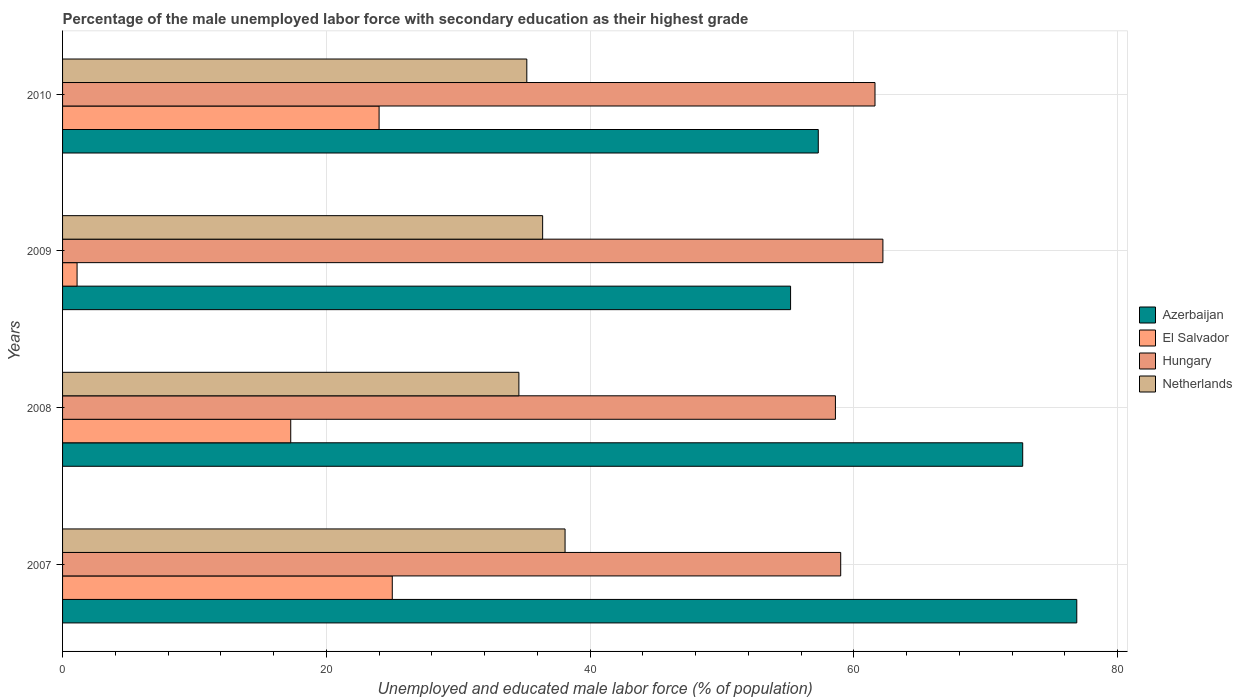How many different coloured bars are there?
Give a very brief answer. 4. Are the number of bars on each tick of the Y-axis equal?
Keep it short and to the point. Yes. How many bars are there on the 3rd tick from the bottom?
Your answer should be very brief. 4. What is the label of the 4th group of bars from the top?
Your answer should be very brief. 2007. What is the percentage of the unemployed male labor force with secondary education in Azerbaijan in 2007?
Provide a succinct answer. 76.9. Across all years, what is the maximum percentage of the unemployed male labor force with secondary education in Hungary?
Offer a very short reply. 62.2. Across all years, what is the minimum percentage of the unemployed male labor force with secondary education in Hungary?
Give a very brief answer. 58.6. In which year was the percentage of the unemployed male labor force with secondary education in El Salvador maximum?
Offer a terse response. 2007. In which year was the percentage of the unemployed male labor force with secondary education in Hungary minimum?
Make the answer very short. 2008. What is the total percentage of the unemployed male labor force with secondary education in Hungary in the graph?
Offer a very short reply. 241.4. What is the difference between the percentage of the unemployed male labor force with secondary education in Hungary in 2008 and that in 2010?
Keep it short and to the point. -3. What is the difference between the percentage of the unemployed male labor force with secondary education in Azerbaijan in 2008 and the percentage of the unemployed male labor force with secondary education in Netherlands in 2007?
Make the answer very short. 34.7. What is the average percentage of the unemployed male labor force with secondary education in Hungary per year?
Keep it short and to the point. 60.35. In the year 2007, what is the difference between the percentage of the unemployed male labor force with secondary education in Netherlands and percentage of the unemployed male labor force with secondary education in Hungary?
Offer a very short reply. -20.9. In how many years, is the percentage of the unemployed male labor force with secondary education in Netherlands greater than 72 %?
Your answer should be very brief. 0. What is the ratio of the percentage of the unemployed male labor force with secondary education in Hungary in 2009 to that in 2010?
Provide a succinct answer. 1.01. Is the difference between the percentage of the unemployed male labor force with secondary education in Netherlands in 2008 and 2009 greater than the difference between the percentage of the unemployed male labor force with secondary education in Hungary in 2008 and 2009?
Keep it short and to the point. Yes. What is the difference between the highest and the second highest percentage of the unemployed male labor force with secondary education in Hungary?
Offer a very short reply. 0.6. What is the difference between the highest and the lowest percentage of the unemployed male labor force with secondary education in El Salvador?
Your answer should be compact. 23.9. Is the sum of the percentage of the unemployed male labor force with secondary education in Netherlands in 2008 and 2009 greater than the maximum percentage of the unemployed male labor force with secondary education in Hungary across all years?
Offer a terse response. Yes. What does the 2nd bar from the top in 2008 represents?
Your answer should be compact. Hungary. What does the 3rd bar from the bottom in 2007 represents?
Your answer should be very brief. Hungary. Are all the bars in the graph horizontal?
Provide a short and direct response. Yes. How many years are there in the graph?
Your answer should be compact. 4. Does the graph contain grids?
Provide a short and direct response. Yes. How are the legend labels stacked?
Provide a short and direct response. Vertical. What is the title of the graph?
Your answer should be compact. Percentage of the male unemployed labor force with secondary education as their highest grade. Does "Cabo Verde" appear as one of the legend labels in the graph?
Ensure brevity in your answer.  No. What is the label or title of the X-axis?
Your answer should be very brief. Unemployed and educated male labor force (% of population). What is the Unemployed and educated male labor force (% of population) in Azerbaijan in 2007?
Offer a terse response. 76.9. What is the Unemployed and educated male labor force (% of population) in Hungary in 2007?
Your answer should be compact. 59. What is the Unemployed and educated male labor force (% of population) in Netherlands in 2007?
Keep it short and to the point. 38.1. What is the Unemployed and educated male labor force (% of population) in Azerbaijan in 2008?
Offer a very short reply. 72.8. What is the Unemployed and educated male labor force (% of population) in El Salvador in 2008?
Offer a very short reply. 17.3. What is the Unemployed and educated male labor force (% of population) in Hungary in 2008?
Provide a short and direct response. 58.6. What is the Unemployed and educated male labor force (% of population) in Netherlands in 2008?
Offer a very short reply. 34.6. What is the Unemployed and educated male labor force (% of population) of Azerbaijan in 2009?
Your answer should be very brief. 55.2. What is the Unemployed and educated male labor force (% of population) in El Salvador in 2009?
Give a very brief answer. 1.1. What is the Unemployed and educated male labor force (% of population) in Hungary in 2009?
Ensure brevity in your answer.  62.2. What is the Unemployed and educated male labor force (% of population) of Netherlands in 2009?
Offer a terse response. 36.4. What is the Unemployed and educated male labor force (% of population) of Azerbaijan in 2010?
Provide a short and direct response. 57.3. What is the Unemployed and educated male labor force (% of population) in El Salvador in 2010?
Make the answer very short. 24. What is the Unemployed and educated male labor force (% of population) of Hungary in 2010?
Offer a very short reply. 61.6. What is the Unemployed and educated male labor force (% of population) in Netherlands in 2010?
Keep it short and to the point. 35.2. Across all years, what is the maximum Unemployed and educated male labor force (% of population) in Azerbaijan?
Keep it short and to the point. 76.9. Across all years, what is the maximum Unemployed and educated male labor force (% of population) of El Salvador?
Give a very brief answer. 25. Across all years, what is the maximum Unemployed and educated male labor force (% of population) of Hungary?
Your answer should be very brief. 62.2. Across all years, what is the maximum Unemployed and educated male labor force (% of population) of Netherlands?
Your answer should be compact. 38.1. Across all years, what is the minimum Unemployed and educated male labor force (% of population) of Azerbaijan?
Your response must be concise. 55.2. Across all years, what is the minimum Unemployed and educated male labor force (% of population) in El Salvador?
Offer a very short reply. 1.1. Across all years, what is the minimum Unemployed and educated male labor force (% of population) of Hungary?
Make the answer very short. 58.6. Across all years, what is the minimum Unemployed and educated male labor force (% of population) of Netherlands?
Your answer should be very brief. 34.6. What is the total Unemployed and educated male labor force (% of population) of Azerbaijan in the graph?
Make the answer very short. 262.2. What is the total Unemployed and educated male labor force (% of population) of El Salvador in the graph?
Make the answer very short. 67.4. What is the total Unemployed and educated male labor force (% of population) of Hungary in the graph?
Ensure brevity in your answer.  241.4. What is the total Unemployed and educated male labor force (% of population) in Netherlands in the graph?
Keep it short and to the point. 144.3. What is the difference between the Unemployed and educated male labor force (% of population) in Azerbaijan in 2007 and that in 2008?
Offer a terse response. 4.1. What is the difference between the Unemployed and educated male labor force (% of population) in Hungary in 2007 and that in 2008?
Offer a very short reply. 0.4. What is the difference between the Unemployed and educated male labor force (% of population) in Azerbaijan in 2007 and that in 2009?
Your response must be concise. 21.7. What is the difference between the Unemployed and educated male labor force (% of population) in El Salvador in 2007 and that in 2009?
Offer a terse response. 23.9. What is the difference between the Unemployed and educated male labor force (% of population) of Azerbaijan in 2007 and that in 2010?
Your response must be concise. 19.6. What is the difference between the Unemployed and educated male labor force (% of population) of El Salvador in 2007 and that in 2010?
Provide a short and direct response. 1. What is the difference between the Unemployed and educated male labor force (% of population) of Hungary in 2007 and that in 2010?
Offer a very short reply. -2.6. What is the difference between the Unemployed and educated male labor force (% of population) of Azerbaijan in 2008 and that in 2009?
Ensure brevity in your answer.  17.6. What is the difference between the Unemployed and educated male labor force (% of population) of Hungary in 2008 and that in 2009?
Provide a succinct answer. -3.6. What is the difference between the Unemployed and educated male labor force (% of population) in Netherlands in 2008 and that in 2009?
Give a very brief answer. -1.8. What is the difference between the Unemployed and educated male labor force (% of population) in Azerbaijan in 2008 and that in 2010?
Ensure brevity in your answer.  15.5. What is the difference between the Unemployed and educated male labor force (% of population) in El Salvador in 2008 and that in 2010?
Your response must be concise. -6.7. What is the difference between the Unemployed and educated male labor force (% of population) in Hungary in 2008 and that in 2010?
Your answer should be very brief. -3. What is the difference between the Unemployed and educated male labor force (% of population) in Netherlands in 2008 and that in 2010?
Keep it short and to the point. -0.6. What is the difference between the Unemployed and educated male labor force (% of population) of Azerbaijan in 2009 and that in 2010?
Make the answer very short. -2.1. What is the difference between the Unemployed and educated male labor force (% of population) of El Salvador in 2009 and that in 2010?
Your response must be concise. -22.9. What is the difference between the Unemployed and educated male labor force (% of population) in Azerbaijan in 2007 and the Unemployed and educated male labor force (% of population) in El Salvador in 2008?
Keep it short and to the point. 59.6. What is the difference between the Unemployed and educated male labor force (% of population) in Azerbaijan in 2007 and the Unemployed and educated male labor force (% of population) in Hungary in 2008?
Keep it short and to the point. 18.3. What is the difference between the Unemployed and educated male labor force (% of population) in Azerbaijan in 2007 and the Unemployed and educated male labor force (% of population) in Netherlands in 2008?
Ensure brevity in your answer.  42.3. What is the difference between the Unemployed and educated male labor force (% of population) of El Salvador in 2007 and the Unemployed and educated male labor force (% of population) of Hungary in 2008?
Your answer should be compact. -33.6. What is the difference between the Unemployed and educated male labor force (% of population) of El Salvador in 2007 and the Unemployed and educated male labor force (% of population) of Netherlands in 2008?
Your answer should be very brief. -9.6. What is the difference between the Unemployed and educated male labor force (% of population) of Hungary in 2007 and the Unemployed and educated male labor force (% of population) of Netherlands in 2008?
Offer a very short reply. 24.4. What is the difference between the Unemployed and educated male labor force (% of population) in Azerbaijan in 2007 and the Unemployed and educated male labor force (% of population) in El Salvador in 2009?
Give a very brief answer. 75.8. What is the difference between the Unemployed and educated male labor force (% of population) in Azerbaijan in 2007 and the Unemployed and educated male labor force (% of population) in Hungary in 2009?
Offer a terse response. 14.7. What is the difference between the Unemployed and educated male labor force (% of population) of Azerbaijan in 2007 and the Unemployed and educated male labor force (% of population) of Netherlands in 2009?
Your answer should be very brief. 40.5. What is the difference between the Unemployed and educated male labor force (% of population) in El Salvador in 2007 and the Unemployed and educated male labor force (% of population) in Hungary in 2009?
Your response must be concise. -37.2. What is the difference between the Unemployed and educated male labor force (% of population) in Hungary in 2007 and the Unemployed and educated male labor force (% of population) in Netherlands in 2009?
Provide a short and direct response. 22.6. What is the difference between the Unemployed and educated male labor force (% of population) of Azerbaijan in 2007 and the Unemployed and educated male labor force (% of population) of El Salvador in 2010?
Make the answer very short. 52.9. What is the difference between the Unemployed and educated male labor force (% of population) in Azerbaijan in 2007 and the Unemployed and educated male labor force (% of population) in Hungary in 2010?
Ensure brevity in your answer.  15.3. What is the difference between the Unemployed and educated male labor force (% of population) in Azerbaijan in 2007 and the Unemployed and educated male labor force (% of population) in Netherlands in 2010?
Your answer should be very brief. 41.7. What is the difference between the Unemployed and educated male labor force (% of population) in El Salvador in 2007 and the Unemployed and educated male labor force (% of population) in Hungary in 2010?
Ensure brevity in your answer.  -36.6. What is the difference between the Unemployed and educated male labor force (% of population) in Hungary in 2007 and the Unemployed and educated male labor force (% of population) in Netherlands in 2010?
Offer a very short reply. 23.8. What is the difference between the Unemployed and educated male labor force (% of population) of Azerbaijan in 2008 and the Unemployed and educated male labor force (% of population) of El Salvador in 2009?
Your answer should be compact. 71.7. What is the difference between the Unemployed and educated male labor force (% of population) in Azerbaijan in 2008 and the Unemployed and educated male labor force (% of population) in Netherlands in 2009?
Offer a very short reply. 36.4. What is the difference between the Unemployed and educated male labor force (% of population) of El Salvador in 2008 and the Unemployed and educated male labor force (% of population) of Hungary in 2009?
Your response must be concise. -44.9. What is the difference between the Unemployed and educated male labor force (% of population) in El Salvador in 2008 and the Unemployed and educated male labor force (% of population) in Netherlands in 2009?
Your answer should be very brief. -19.1. What is the difference between the Unemployed and educated male labor force (% of population) of Hungary in 2008 and the Unemployed and educated male labor force (% of population) of Netherlands in 2009?
Offer a very short reply. 22.2. What is the difference between the Unemployed and educated male labor force (% of population) of Azerbaijan in 2008 and the Unemployed and educated male labor force (% of population) of El Salvador in 2010?
Keep it short and to the point. 48.8. What is the difference between the Unemployed and educated male labor force (% of population) of Azerbaijan in 2008 and the Unemployed and educated male labor force (% of population) of Netherlands in 2010?
Offer a very short reply. 37.6. What is the difference between the Unemployed and educated male labor force (% of population) of El Salvador in 2008 and the Unemployed and educated male labor force (% of population) of Hungary in 2010?
Provide a short and direct response. -44.3. What is the difference between the Unemployed and educated male labor force (% of population) in El Salvador in 2008 and the Unemployed and educated male labor force (% of population) in Netherlands in 2010?
Offer a very short reply. -17.9. What is the difference between the Unemployed and educated male labor force (% of population) in Hungary in 2008 and the Unemployed and educated male labor force (% of population) in Netherlands in 2010?
Give a very brief answer. 23.4. What is the difference between the Unemployed and educated male labor force (% of population) in Azerbaijan in 2009 and the Unemployed and educated male labor force (% of population) in El Salvador in 2010?
Give a very brief answer. 31.2. What is the difference between the Unemployed and educated male labor force (% of population) of Azerbaijan in 2009 and the Unemployed and educated male labor force (% of population) of Netherlands in 2010?
Make the answer very short. 20. What is the difference between the Unemployed and educated male labor force (% of population) of El Salvador in 2009 and the Unemployed and educated male labor force (% of population) of Hungary in 2010?
Make the answer very short. -60.5. What is the difference between the Unemployed and educated male labor force (% of population) of El Salvador in 2009 and the Unemployed and educated male labor force (% of population) of Netherlands in 2010?
Your answer should be compact. -34.1. What is the difference between the Unemployed and educated male labor force (% of population) in Hungary in 2009 and the Unemployed and educated male labor force (% of population) in Netherlands in 2010?
Your answer should be very brief. 27. What is the average Unemployed and educated male labor force (% of population) of Azerbaijan per year?
Make the answer very short. 65.55. What is the average Unemployed and educated male labor force (% of population) of El Salvador per year?
Offer a very short reply. 16.85. What is the average Unemployed and educated male labor force (% of population) of Hungary per year?
Keep it short and to the point. 60.35. What is the average Unemployed and educated male labor force (% of population) in Netherlands per year?
Offer a very short reply. 36.08. In the year 2007, what is the difference between the Unemployed and educated male labor force (% of population) of Azerbaijan and Unemployed and educated male labor force (% of population) of El Salvador?
Make the answer very short. 51.9. In the year 2007, what is the difference between the Unemployed and educated male labor force (% of population) of Azerbaijan and Unemployed and educated male labor force (% of population) of Netherlands?
Provide a succinct answer. 38.8. In the year 2007, what is the difference between the Unemployed and educated male labor force (% of population) in El Salvador and Unemployed and educated male labor force (% of population) in Hungary?
Your response must be concise. -34. In the year 2007, what is the difference between the Unemployed and educated male labor force (% of population) in El Salvador and Unemployed and educated male labor force (% of population) in Netherlands?
Provide a short and direct response. -13.1. In the year 2007, what is the difference between the Unemployed and educated male labor force (% of population) of Hungary and Unemployed and educated male labor force (% of population) of Netherlands?
Ensure brevity in your answer.  20.9. In the year 2008, what is the difference between the Unemployed and educated male labor force (% of population) of Azerbaijan and Unemployed and educated male labor force (% of population) of El Salvador?
Offer a very short reply. 55.5. In the year 2008, what is the difference between the Unemployed and educated male labor force (% of population) of Azerbaijan and Unemployed and educated male labor force (% of population) of Hungary?
Keep it short and to the point. 14.2. In the year 2008, what is the difference between the Unemployed and educated male labor force (% of population) in Azerbaijan and Unemployed and educated male labor force (% of population) in Netherlands?
Make the answer very short. 38.2. In the year 2008, what is the difference between the Unemployed and educated male labor force (% of population) in El Salvador and Unemployed and educated male labor force (% of population) in Hungary?
Your response must be concise. -41.3. In the year 2008, what is the difference between the Unemployed and educated male labor force (% of population) in El Salvador and Unemployed and educated male labor force (% of population) in Netherlands?
Ensure brevity in your answer.  -17.3. In the year 2009, what is the difference between the Unemployed and educated male labor force (% of population) in Azerbaijan and Unemployed and educated male labor force (% of population) in El Salvador?
Give a very brief answer. 54.1. In the year 2009, what is the difference between the Unemployed and educated male labor force (% of population) in El Salvador and Unemployed and educated male labor force (% of population) in Hungary?
Provide a short and direct response. -61.1. In the year 2009, what is the difference between the Unemployed and educated male labor force (% of population) in El Salvador and Unemployed and educated male labor force (% of population) in Netherlands?
Provide a short and direct response. -35.3. In the year 2009, what is the difference between the Unemployed and educated male labor force (% of population) of Hungary and Unemployed and educated male labor force (% of population) of Netherlands?
Give a very brief answer. 25.8. In the year 2010, what is the difference between the Unemployed and educated male labor force (% of population) in Azerbaijan and Unemployed and educated male labor force (% of population) in El Salvador?
Offer a very short reply. 33.3. In the year 2010, what is the difference between the Unemployed and educated male labor force (% of population) of Azerbaijan and Unemployed and educated male labor force (% of population) of Netherlands?
Offer a very short reply. 22.1. In the year 2010, what is the difference between the Unemployed and educated male labor force (% of population) of El Salvador and Unemployed and educated male labor force (% of population) of Hungary?
Provide a short and direct response. -37.6. In the year 2010, what is the difference between the Unemployed and educated male labor force (% of population) in Hungary and Unemployed and educated male labor force (% of population) in Netherlands?
Ensure brevity in your answer.  26.4. What is the ratio of the Unemployed and educated male labor force (% of population) in Azerbaijan in 2007 to that in 2008?
Provide a short and direct response. 1.06. What is the ratio of the Unemployed and educated male labor force (% of population) in El Salvador in 2007 to that in 2008?
Your answer should be very brief. 1.45. What is the ratio of the Unemployed and educated male labor force (% of population) of Hungary in 2007 to that in 2008?
Make the answer very short. 1.01. What is the ratio of the Unemployed and educated male labor force (% of population) of Netherlands in 2007 to that in 2008?
Ensure brevity in your answer.  1.1. What is the ratio of the Unemployed and educated male labor force (% of population) of Azerbaijan in 2007 to that in 2009?
Offer a terse response. 1.39. What is the ratio of the Unemployed and educated male labor force (% of population) in El Salvador in 2007 to that in 2009?
Offer a very short reply. 22.73. What is the ratio of the Unemployed and educated male labor force (% of population) of Hungary in 2007 to that in 2009?
Your answer should be very brief. 0.95. What is the ratio of the Unemployed and educated male labor force (% of population) in Netherlands in 2007 to that in 2009?
Your answer should be compact. 1.05. What is the ratio of the Unemployed and educated male labor force (% of population) of Azerbaijan in 2007 to that in 2010?
Offer a terse response. 1.34. What is the ratio of the Unemployed and educated male labor force (% of population) in El Salvador in 2007 to that in 2010?
Your answer should be compact. 1.04. What is the ratio of the Unemployed and educated male labor force (% of population) of Hungary in 2007 to that in 2010?
Your answer should be very brief. 0.96. What is the ratio of the Unemployed and educated male labor force (% of population) in Netherlands in 2007 to that in 2010?
Give a very brief answer. 1.08. What is the ratio of the Unemployed and educated male labor force (% of population) of Azerbaijan in 2008 to that in 2009?
Your answer should be very brief. 1.32. What is the ratio of the Unemployed and educated male labor force (% of population) of El Salvador in 2008 to that in 2009?
Your answer should be very brief. 15.73. What is the ratio of the Unemployed and educated male labor force (% of population) of Hungary in 2008 to that in 2009?
Make the answer very short. 0.94. What is the ratio of the Unemployed and educated male labor force (% of population) of Netherlands in 2008 to that in 2009?
Offer a terse response. 0.95. What is the ratio of the Unemployed and educated male labor force (% of population) of Azerbaijan in 2008 to that in 2010?
Your response must be concise. 1.27. What is the ratio of the Unemployed and educated male labor force (% of population) of El Salvador in 2008 to that in 2010?
Your answer should be compact. 0.72. What is the ratio of the Unemployed and educated male labor force (% of population) of Hungary in 2008 to that in 2010?
Provide a succinct answer. 0.95. What is the ratio of the Unemployed and educated male labor force (% of population) of Netherlands in 2008 to that in 2010?
Offer a very short reply. 0.98. What is the ratio of the Unemployed and educated male labor force (% of population) in Azerbaijan in 2009 to that in 2010?
Keep it short and to the point. 0.96. What is the ratio of the Unemployed and educated male labor force (% of population) in El Salvador in 2009 to that in 2010?
Your answer should be compact. 0.05. What is the ratio of the Unemployed and educated male labor force (% of population) of Hungary in 2009 to that in 2010?
Give a very brief answer. 1.01. What is the ratio of the Unemployed and educated male labor force (% of population) of Netherlands in 2009 to that in 2010?
Make the answer very short. 1.03. What is the difference between the highest and the second highest Unemployed and educated male labor force (% of population) in El Salvador?
Make the answer very short. 1. What is the difference between the highest and the second highest Unemployed and educated male labor force (% of population) in Netherlands?
Ensure brevity in your answer.  1.7. What is the difference between the highest and the lowest Unemployed and educated male labor force (% of population) of Azerbaijan?
Ensure brevity in your answer.  21.7. What is the difference between the highest and the lowest Unemployed and educated male labor force (% of population) of El Salvador?
Provide a short and direct response. 23.9. What is the difference between the highest and the lowest Unemployed and educated male labor force (% of population) of Hungary?
Your answer should be very brief. 3.6. What is the difference between the highest and the lowest Unemployed and educated male labor force (% of population) of Netherlands?
Keep it short and to the point. 3.5. 